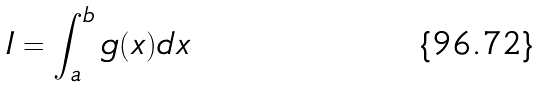Convert formula to latex. <formula><loc_0><loc_0><loc_500><loc_500>I = \int _ { a } ^ { b } g ( x ) d x</formula> 